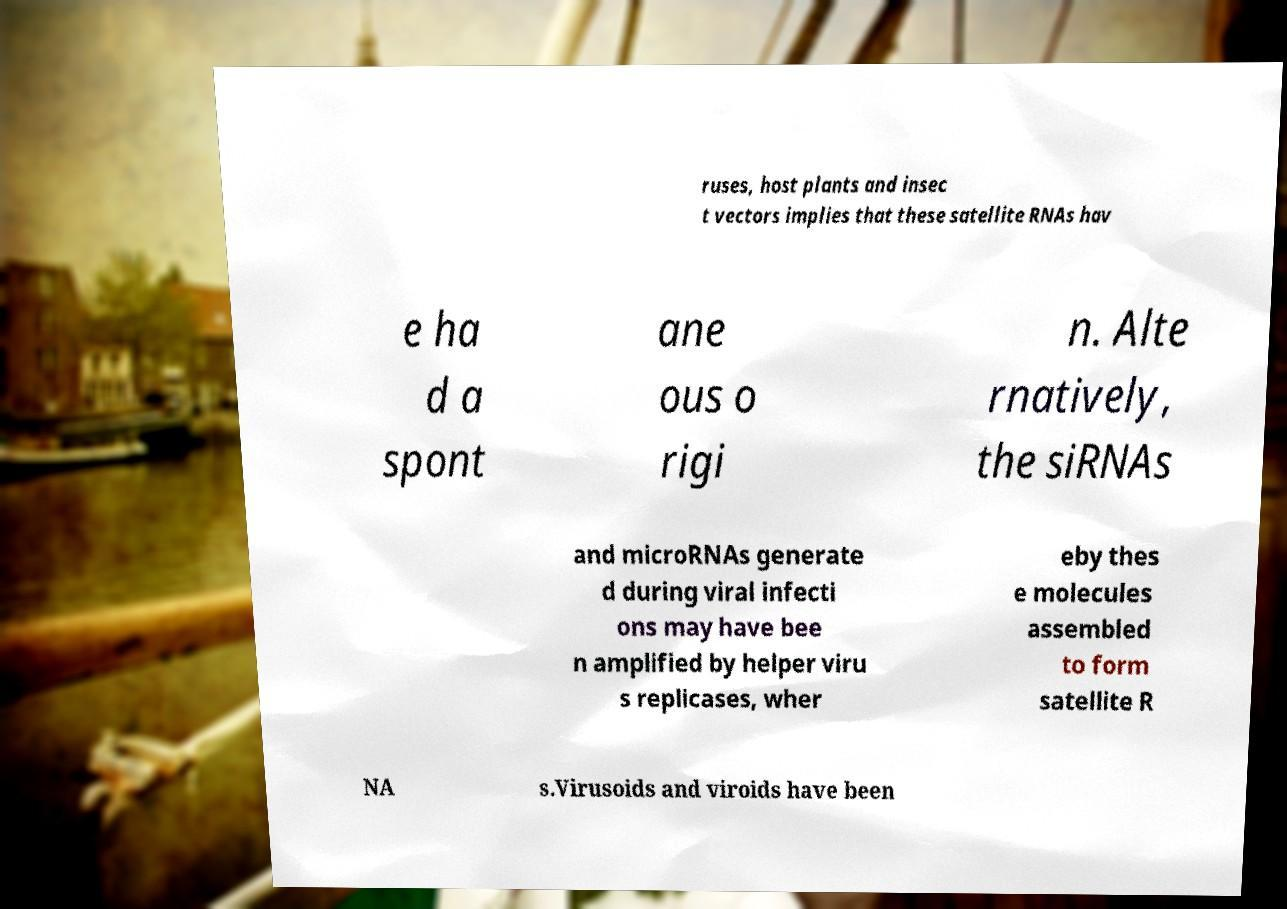Could you extract and type out the text from this image? ruses, host plants and insec t vectors implies that these satellite RNAs hav e ha d a spont ane ous o rigi n. Alte rnatively, the siRNAs and microRNAs generate d during viral infecti ons may have bee n amplified by helper viru s replicases, wher eby thes e molecules assembled to form satellite R NA s.Virusoids and viroids have been 